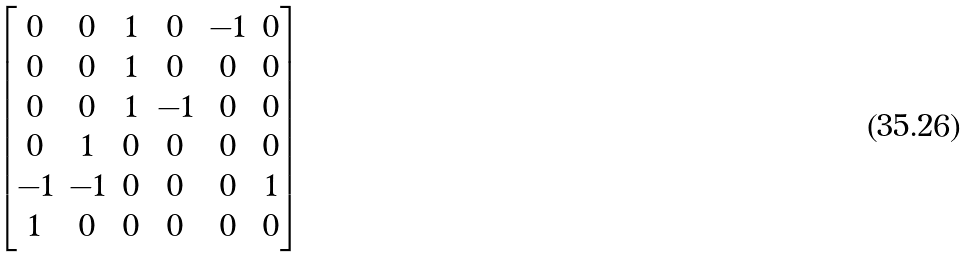Convert formula to latex. <formula><loc_0><loc_0><loc_500><loc_500>\begin{bmatrix} 0 & 0 & 1 & 0 & - 1 & 0 \\ 0 & 0 & 1 & 0 & 0 & 0 \\ 0 & 0 & 1 & - 1 & 0 & 0 \\ 0 & 1 & 0 & 0 & 0 & 0 \\ - 1 & - 1 & 0 & 0 & 0 & 1 \\ 1 & 0 & 0 & 0 & 0 & 0 \end{bmatrix}</formula> 